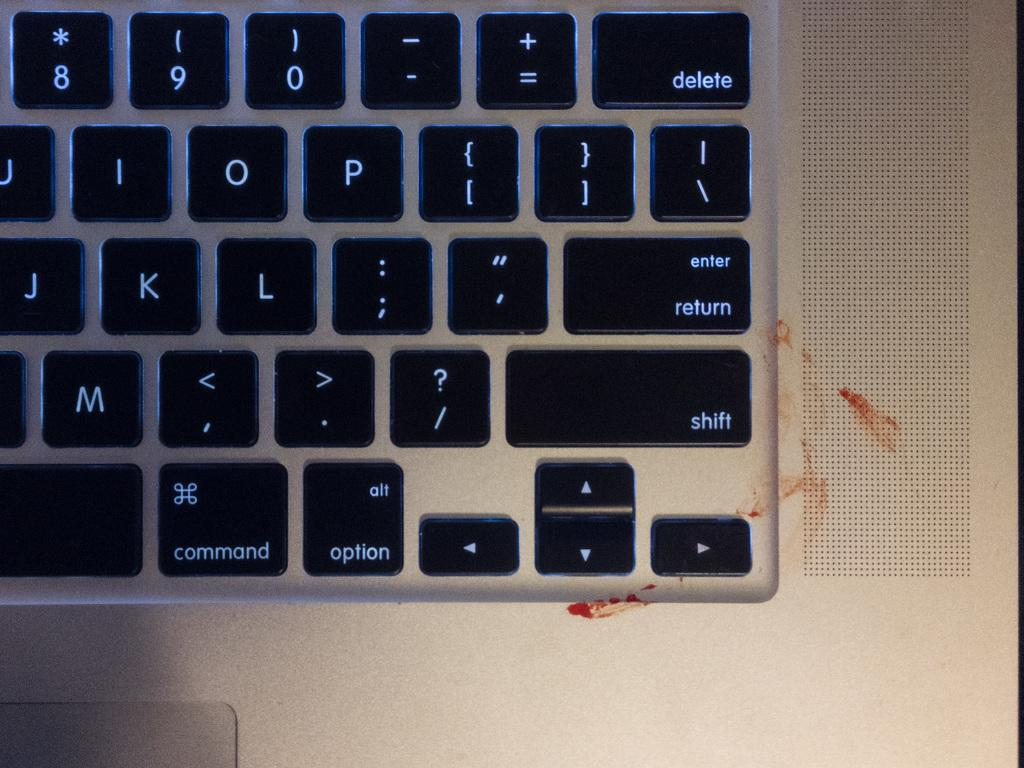<image>
Share a concise interpretation of the image provided. The numbers 8,9 and 0 are visible on this keyboard. 